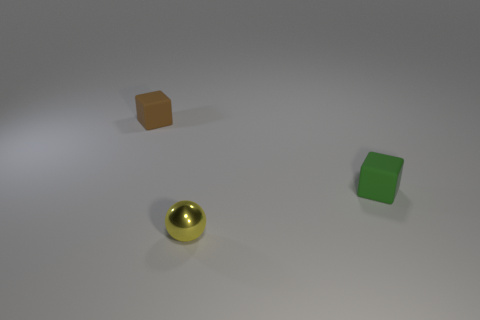How big is the thing behind the matte thing that is on the right side of the tiny brown rubber block?
Give a very brief answer. Small. Is the number of green matte things on the left side of the yellow thing less than the number of yellow shiny balls that are to the left of the green rubber object?
Your answer should be compact. Yes. The metallic thing is what color?
Provide a short and direct response. Yellow. The matte object that is in front of the rubber cube that is left of the small matte thing that is to the right of the brown matte thing is what shape?
Provide a short and direct response. Cube. What material is the yellow sphere that is in front of the green thing?
Make the answer very short. Metal. What is the size of the cube that is left of the small matte thing that is in front of the cube that is on the left side of the green rubber block?
Provide a short and direct response. Small. What color is the tiny matte object to the right of the brown rubber thing?
Your answer should be compact. Green. What shape is the thing that is left of the small yellow metallic sphere?
Offer a terse response. Cube. What number of brown things are either matte blocks or metallic things?
Provide a short and direct response. 1. Is the material of the tiny yellow thing the same as the brown cube?
Keep it short and to the point. No. 